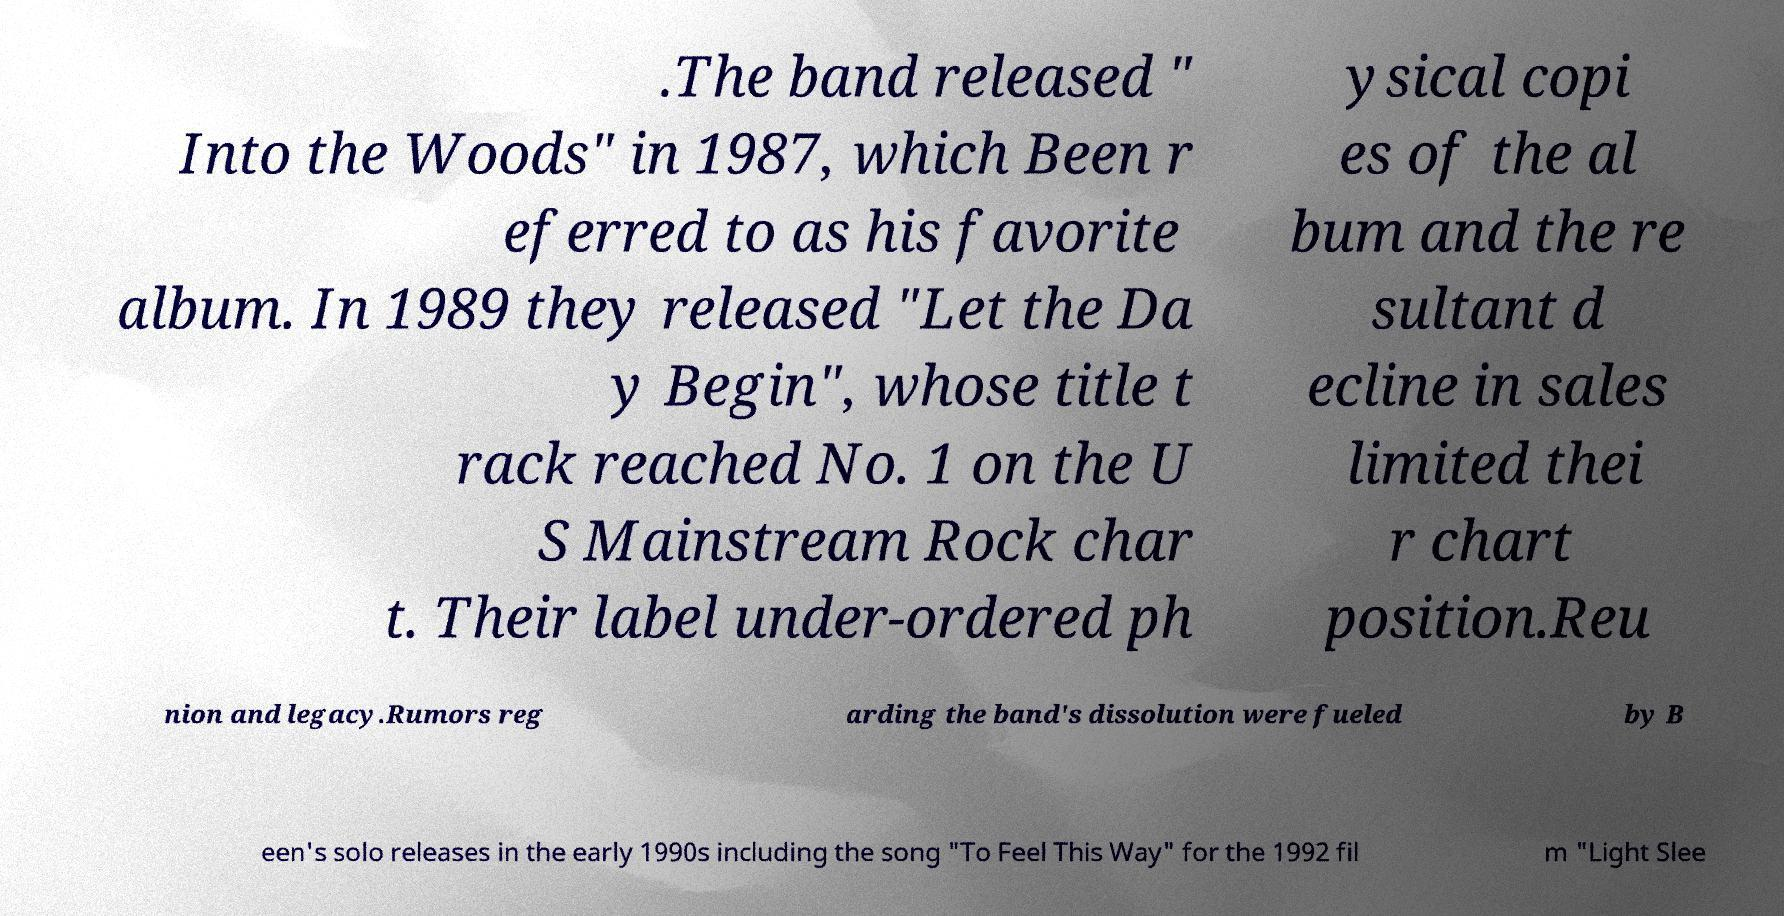Could you extract and type out the text from this image? .The band released " Into the Woods" in 1987, which Been r eferred to as his favorite album. In 1989 they released "Let the Da y Begin", whose title t rack reached No. 1 on the U S Mainstream Rock char t. Their label under-ordered ph ysical copi es of the al bum and the re sultant d ecline in sales limited thei r chart position.Reu nion and legacy.Rumors reg arding the band's dissolution were fueled by B een's solo releases in the early 1990s including the song "To Feel This Way" for the 1992 fil m "Light Slee 